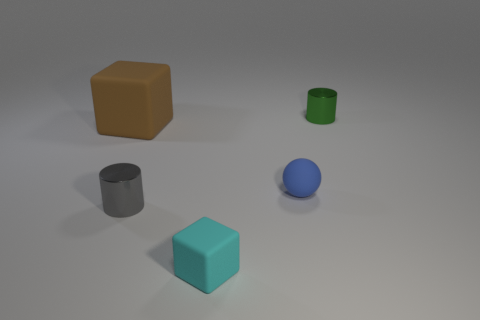Are there fewer gray cylinders left of the brown matte object than cylinders?
Give a very brief answer. Yes. What is the color of the matte ball that is the same size as the green cylinder?
Provide a succinct answer. Blue. How many tiny objects have the same shape as the large thing?
Ensure brevity in your answer.  1. There is a tiny metallic object that is right of the small blue sphere; what is its color?
Offer a terse response. Green. How many rubber objects are either cylinders or gray objects?
Keep it short and to the point. 0. How many blue matte objects have the same size as the gray metal cylinder?
Your answer should be compact. 1. There is a thing that is both behind the blue matte ball and on the left side of the blue rubber ball; what is its color?
Your answer should be compact. Brown. How many objects are red matte cylinders or small cyan matte objects?
Ensure brevity in your answer.  1. How many tiny objects are either green cylinders or shiny things?
Keep it short and to the point. 2. Is there anything else that has the same color as the tiny rubber cube?
Your answer should be very brief. No. 